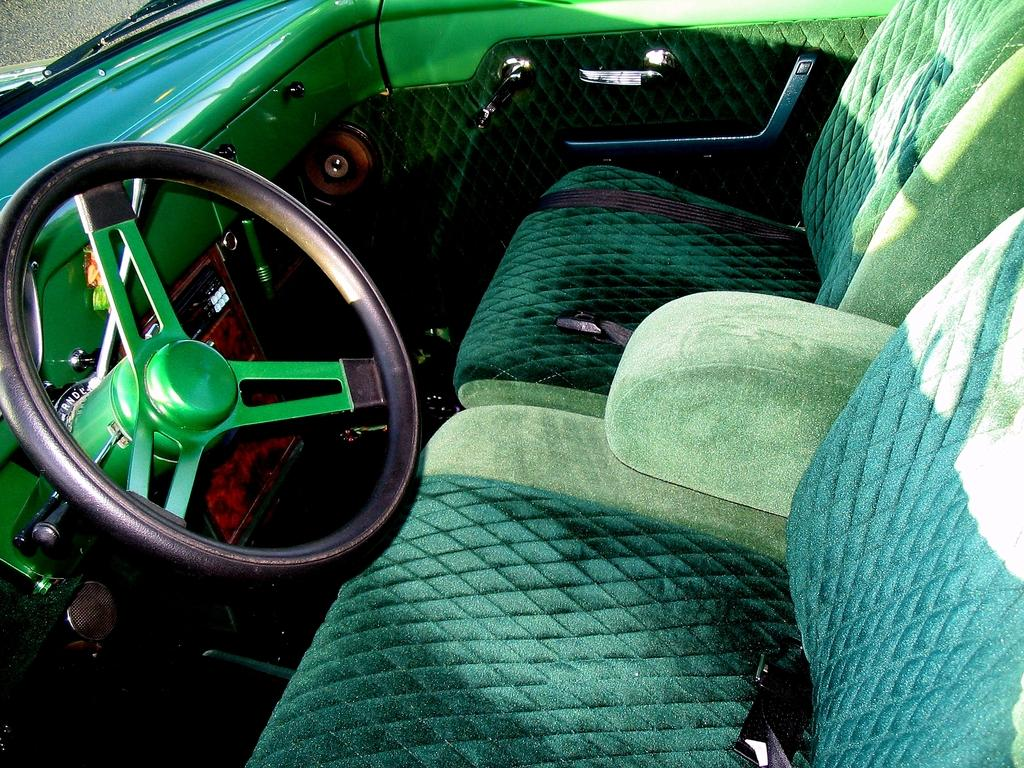What is the main object in the image? There is a steering wheel in the image. What colors are used for the steering wheel? The steering wheel is black and green in color. How many seats are visible in the image? There are two seats in the image. What color are the seat belts? The seat belts are green in color. How many frogs are sitting on the steering wheel in the image? There are no frogs present in the image; the steering wheel is the main object. 